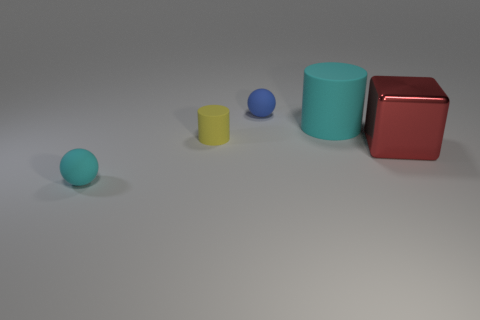Add 4 large cyan spheres. How many objects exist? 9 Subtract all cubes. How many objects are left? 4 Subtract all brown shiny objects. Subtract all big red shiny things. How many objects are left? 4 Add 2 blue balls. How many blue balls are left? 3 Add 1 cyan matte balls. How many cyan matte balls exist? 2 Subtract 1 cyan cylinders. How many objects are left? 4 